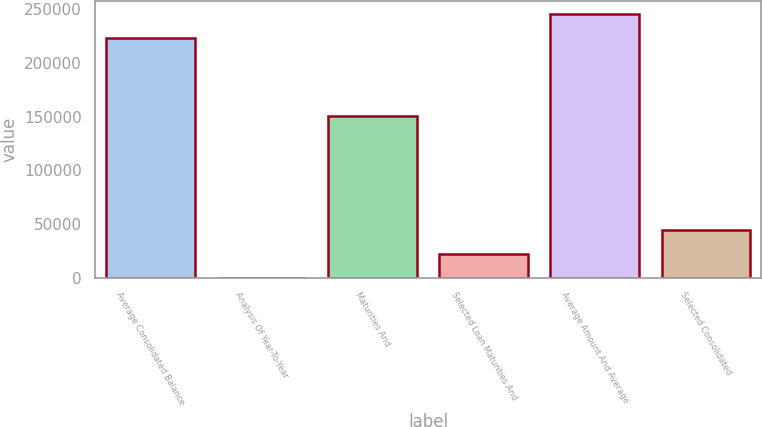<chart> <loc_0><loc_0><loc_500><loc_500><bar_chart><fcel>Average Consolidated Balance<fcel>Analysis Of Year-To-Year<fcel>Maturities And<fcel>Selected Loan Maturities And<fcel>Average Amount And Average<fcel>Selected Consolidated<nl><fcel>223224<fcel>225<fcel>150151<fcel>22524.9<fcel>245524<fcel>44824.8<nl></chart> 